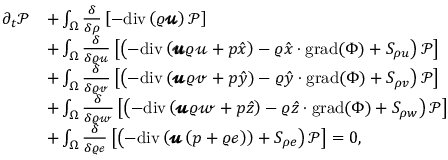<formula> <loc_0><loc_0><loc_500><loc_500>\begin{array} { r l } { \partial _ { t } \mathcal { P } } & { + \int _ { \Omega } \frac { \delta } { \delta \rho } \left [ - d i v \left ( \varrho \pm b { \ m a t h s c r { u } } \right ) \mathcal { P } \right ] } \\ & { + \int _ { \Omega } \frac { \delta } { \delta \varrho \ m a t h s c r { u } } \left [ \left ( - d i v \left ( \pm b { \ m a t h s c r { u } } \varrho \ m a t h s c r { u } + p \hat { x } \right ) - \varrho \hat { x } \cdot g r a d ( \Phi ) + S _ { \rho u } \right ) \mathcal { P } \right ] } \\ & { + \int _ { \Omega } \frac { \delta } { \delta \varrho \ m a t h s c r { v } } \left [ \left ( - d i v \left ( \pm b { \ m a t h s c r { u } } \varrho \ m a t h s c r { v } + p \hat { y } \right ) - \varrho \hat { y } \cdot g r a d ( \Phi ) + S _ { \rho v } \right ) \mathcal { P } \right ] } \\ & { + \int _ { \Omega } \frac { \delta } { \delta \varrho \ m a t h s c r { w } } \left [ \left ( - d i v \left ( \pm b { \ m a t h s c r { u } } \varrho \ m a t h s c r { w } + p \hat { z } \right ) - \varrho \hat { z } \cdot g r a d ( \Phi ) + S _ { \rho w } \right ) \mathcal { P } \right ] } \\ & { + \int _ { \Omega } \frac { \delta } { \delta \varrho \ m a t h s c r { e } } \left [ \left ( - d i v \left ( \pm b { \ m a t h s c r { u } } \left ( p + \varrho \ m a t h s c r { e } \right ) \right ) + S _ { \rho e } \right ) \mathcal { P } \right ] = 0 , } \end{array}</formula> 